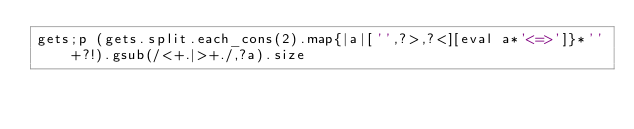<code> <loc_0><loc_0><loc_500><loc_500><_Ruby_>gets;p (gets.split.each_cons(2).map{|a|['',?>,?<][eval a*'<=>']}*''+?!).gsub(/<+.|>+./,?a).size</code> 